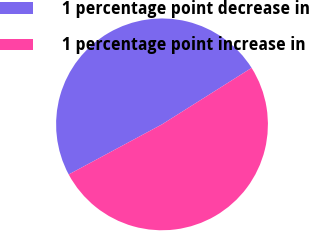Convert chart to OTSL. <chart><loc_0><loc_0><loc_500><loc_500><pie_chart><fcel>1 percentage point decrease in<fcel>1 percentage point increase in<nl><fcel>48.89%<fcel>51.11%<nl></chart> 